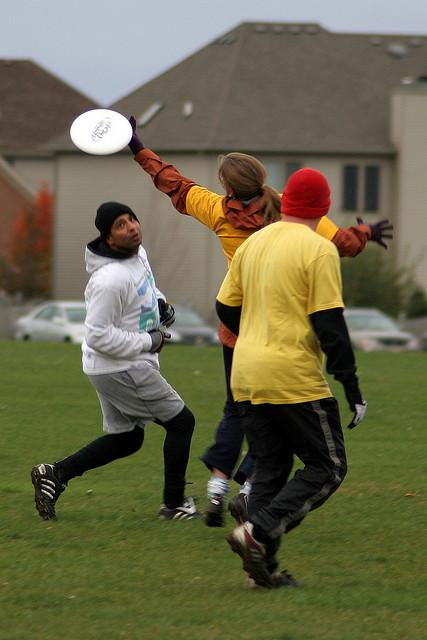What sport is being played?

Choices:
A) hockey
B) soccer
C) ultimate frisbee
D) football ultimate frisbee 